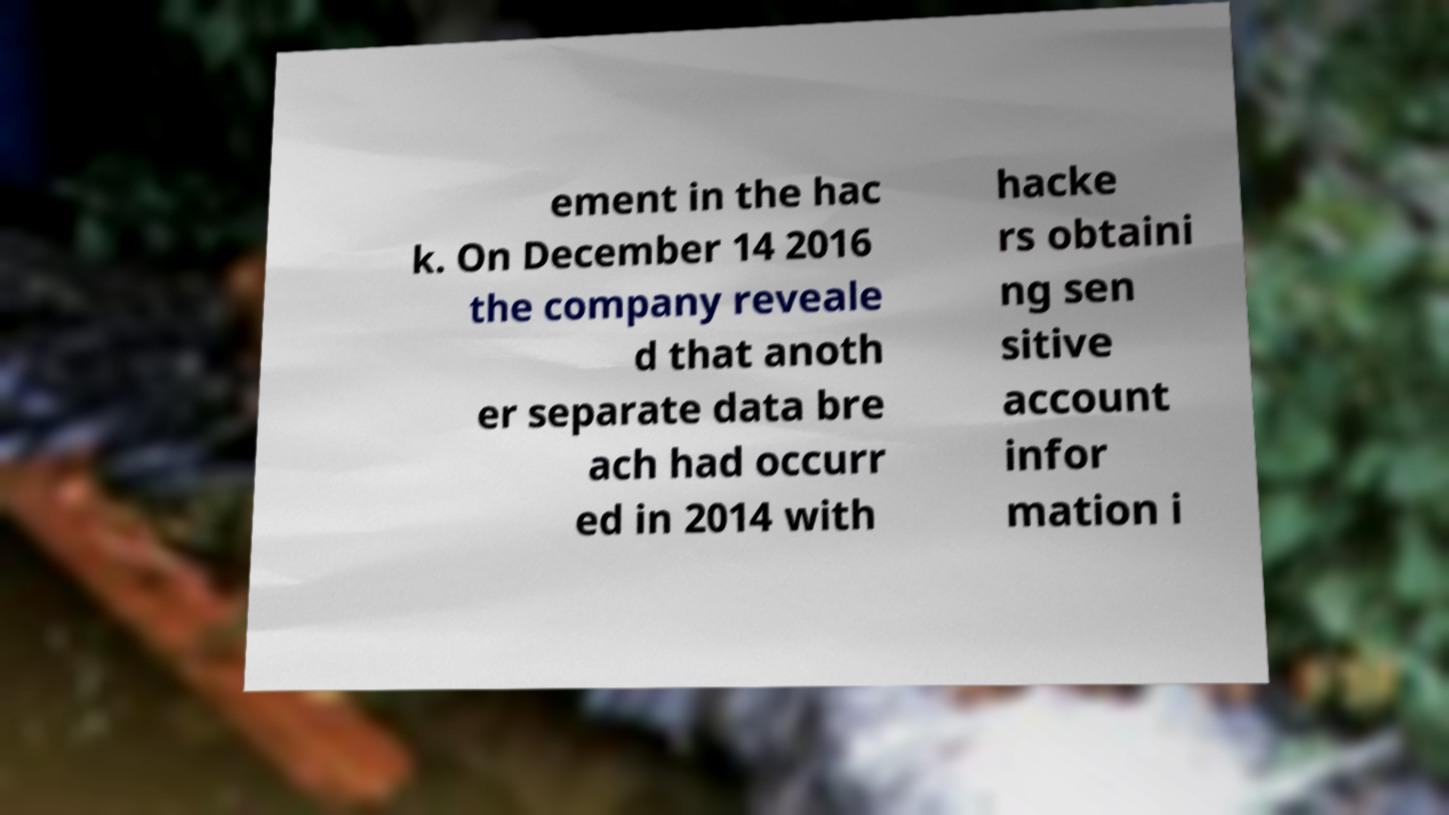I need the written content from this picture converted into text. Can you do that? ement in the hac k. On December 14 2016 the company reveale d that anoth er separate data bre ach had occurr ed in 2014 with hacke rs obtaini ng sen sitive account infor mation i 